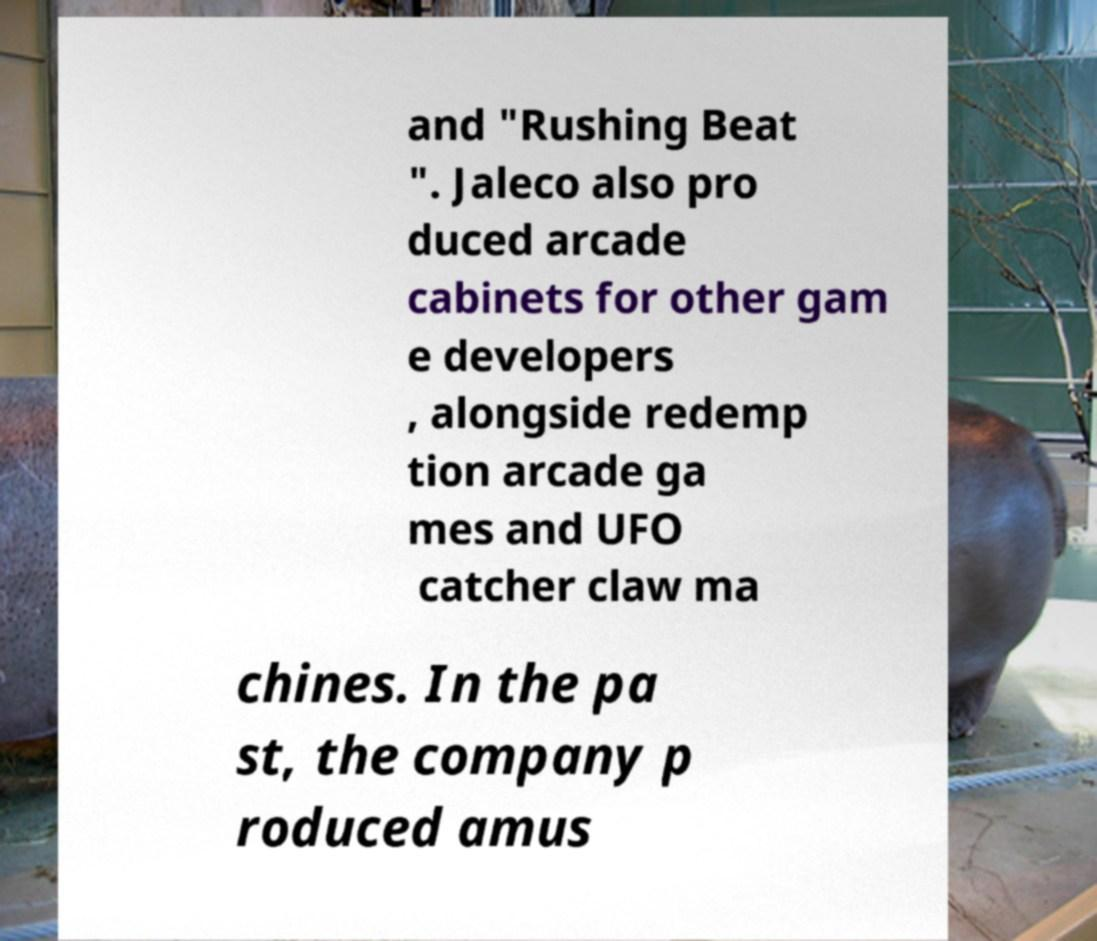I need the written content from this picture converted into text. Can you do that? and "Rushing Beat ". Jaleco also pro duced arcade cabinets for other gam e developers , alongside redemp tion arcade ga mes and UFO catcher claw ma chines. In the pa st, the company p roduced amus 